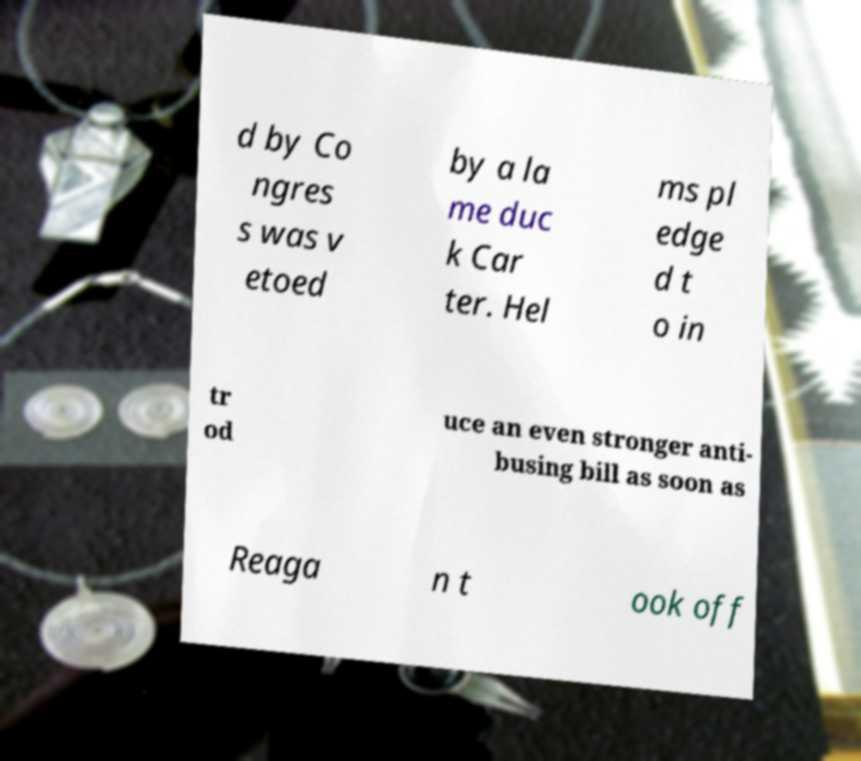Can you read and provide the text displayed in the image?This photo seems to have some interesting text. Can you extract and type it out for me? d by Co ngres s was v etoed by a la me duc k Car ter. Hel ms pl edge d t o in tr od uce an even stronger anti- busing bill as soon as Reaga n t ook off 